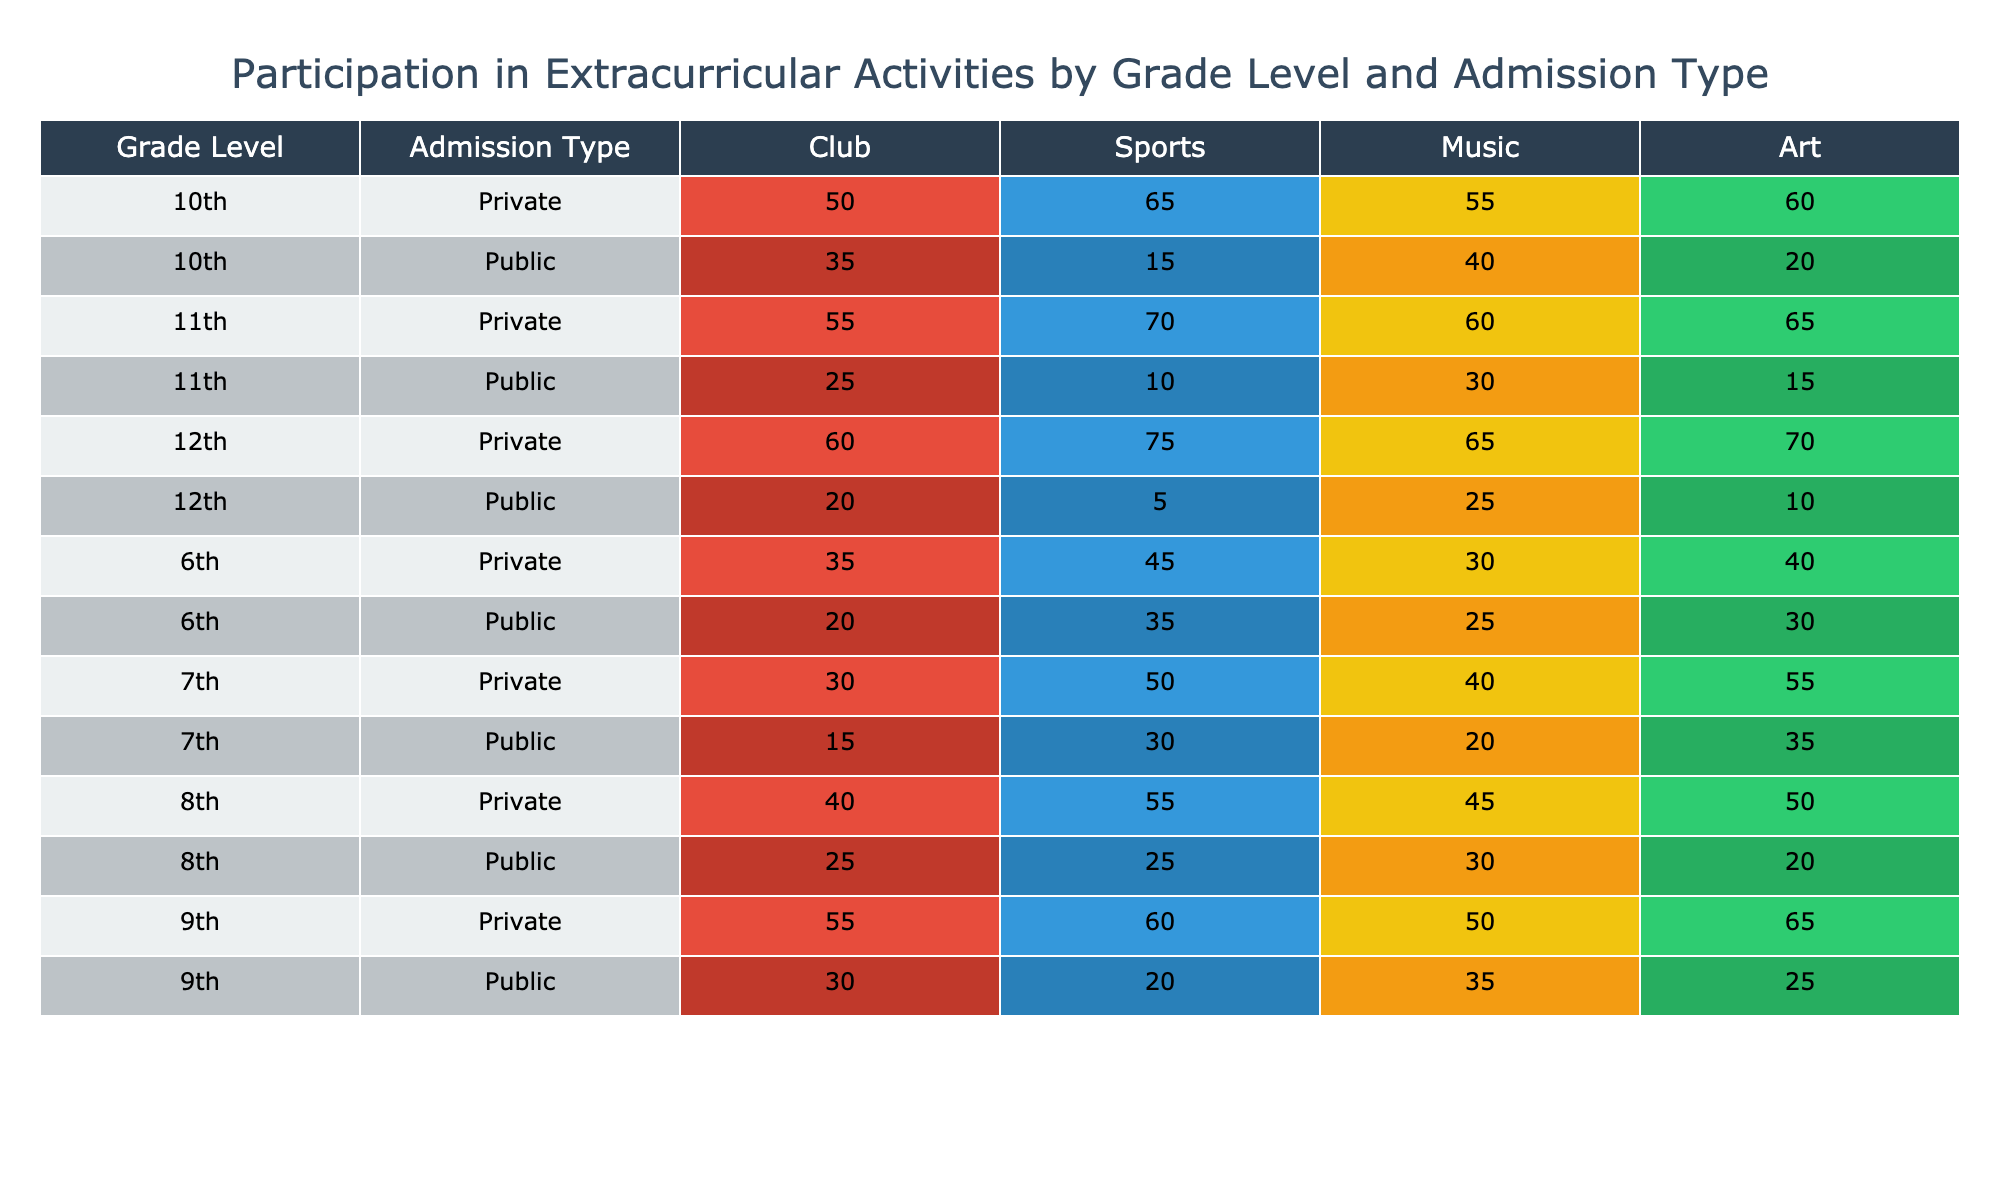What is the highest club participation percentage among 7th graders? Looking at the table, the club participation percentage for 7th Public is 30, while for 7th Private, it is 50. The highest value is clearly 50.
Answer: 50 Which grade level has the lowest art participation in public schools? The table shows that 8th Public has the lowest art participation at 25, compared to other grades in public schools.
Answer: 25 What is the total sports participation for 10th grade students in both public and private schools? The table lists sports participation for 10th Public as 20 and for 10th Private as 60. Adding these values gives a total of 20 + 60 = 80.
Answer: 80 Is music participation higher for Private schools or Public schools in the 9th grade? For 9th graders, Public music participation is listed as 35, while Private music participation is higher at 50. Therefore, Private schools have higher music participation for 9th graders.
Answer: Yes What is the average club participation across all grade levels for private school students? To find the average, we calculate the sum of club participation for all private grades: 45 (6th) + 50 (7th) + 55 (8th) + 60 (9th) + 65 (10th) + 70 (11th) + 75 (12th) = 450. Dividing this by the 7 grades gives 450 / 7 = approximately 64.29.
Answer: 64.29 In which grade level does sports participation drop below 20 for Public schools? The table indicates that the sports participation for 8th Public is 20, meaning it does not drop below 20 for this grade level. All values for public sport participation in grades 6, 7, 8, 9, 10, 11, and 12 are either above or exactly 20.
Answer: No What is the difference in art participation between the highest Active Participation grade in private and public schools? The highest art participation in private schools is 60 (12th grade), while in public schools, it is 25 (8th grade). The difference is 60 - 25 = 35.
Answer: 35 